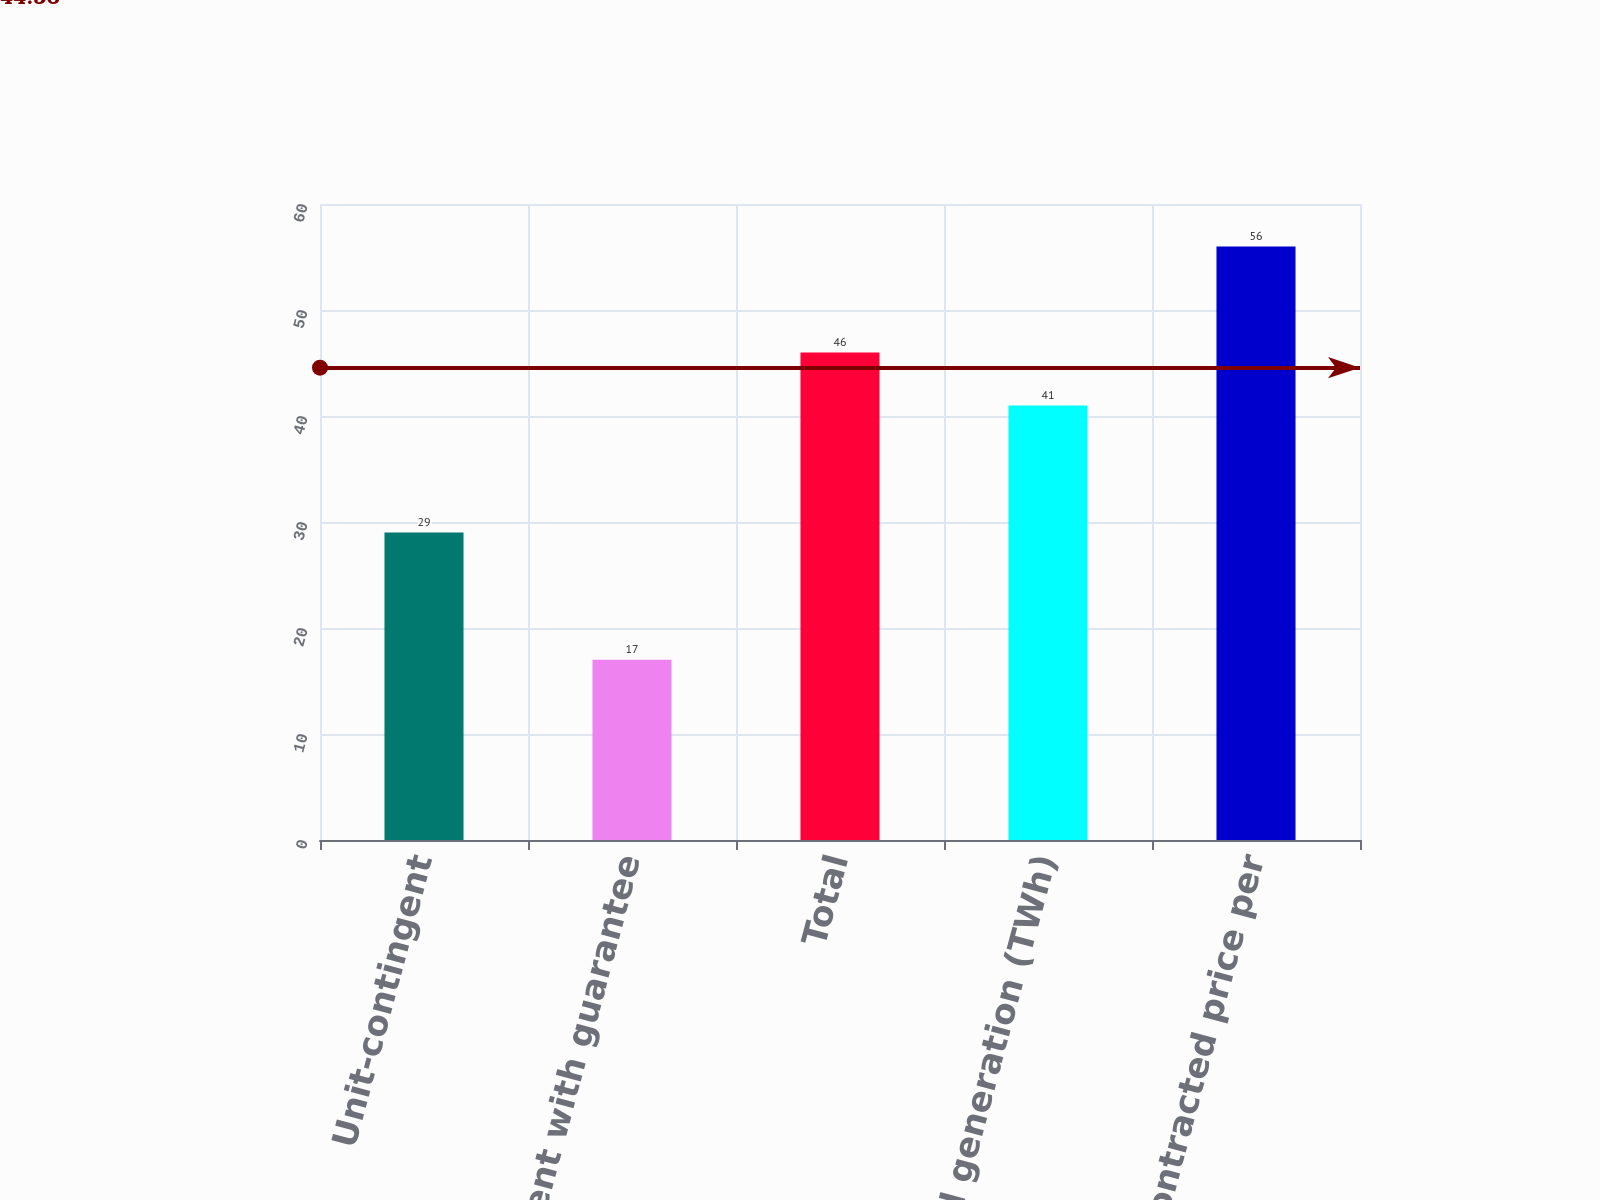Convert chart. <chart><loc_0><loc_0><loc_500><loc_500><bar_chart><fcel>Unit-contingent<fcel>Unit-contingent with guarantee<fcel>Total<fcel>Planned generation (TWh)<fcel>Average contracted price per<nl><fcel>29<fcel>17<fcel>46<fcel>41<fcel>56<nl></chart> 